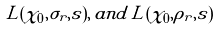<formula> <loc_0><loc_0><loc_500><loc_500>L ( \chi _ { 0 } , \sigma _ { r } , s ) , \, a n d \, L ( \chi _ { 0 } , \rho _ { r } , s )</formula> 